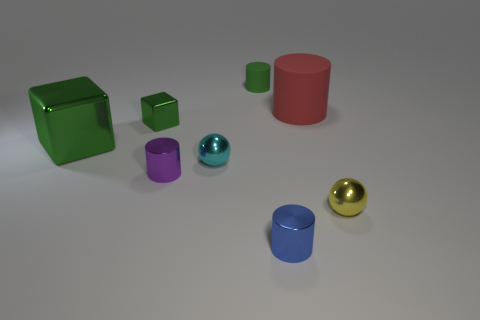Are the green cylinder and the large cylinder made of the same material?
Provide a short and direct response. Yes. How many other things are there of the same size as the red cylinder?
Your response must be concise. 1. Are there any big red cylinders?
Offer a terse response. Yes. There is a green metallic thing in front of the green block behind the big green thing; what is its size?
Your answer should be very brief. Large. There is a shiny thing that is behind the big green metallic object; is it the same color as the large object on the left side of the small blue metallic object?
Offer a very short reply. Yes. The small thing that is both behind the large green cube and to the left of the green rubber cylinder is what color?
Your answer should be compact. Green. How many other things are there of the same shape as the red rubber object?
Offer a very short reply. 3. What is the color of the block that is the same size as the green rubber thing?
Offer a terse response. Green. The metallic ball on the right side of the tiny cyan ball is what color?
Your answer should be very brief. Yellow. There is a large thing that is in front of the tiny cube; are there any green metal blocks that are behind it?
Ensure brevity in your answer.  Yes. 